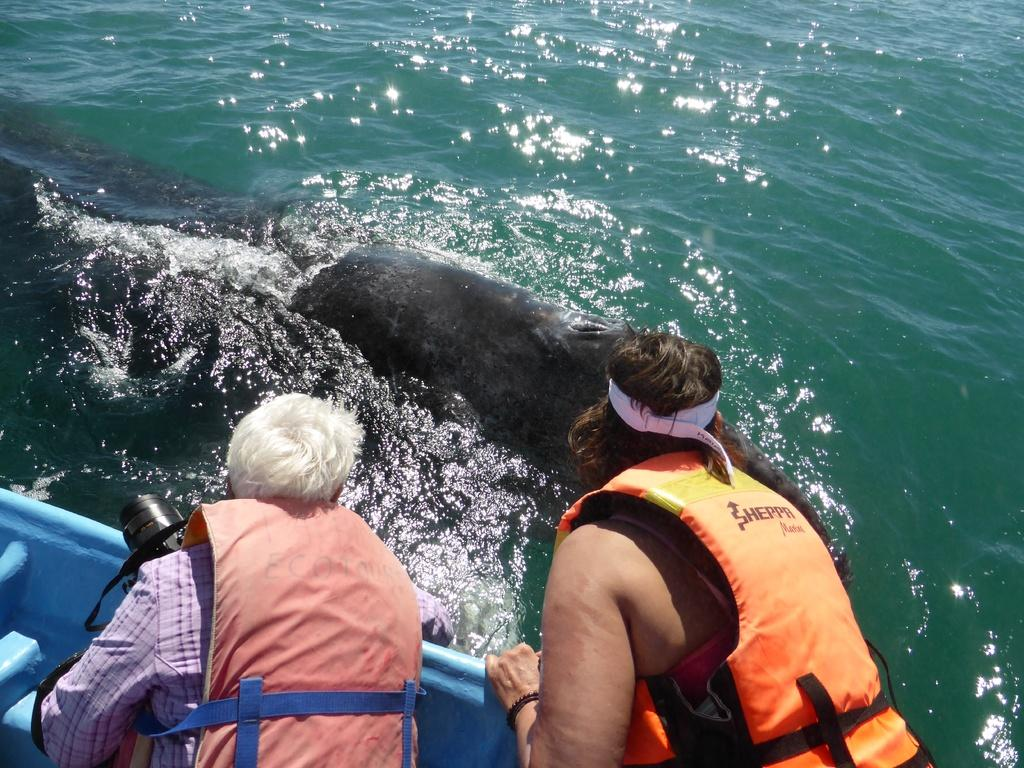What is the animal doing in the water? The animal is in the water, but the specific action is not mentioned in the facts. How many people are in the image? There are two persons in the image. What are the two persons doing in the image? The two persons are sailing on a boat. What might the person holding the camera be doing? The person holding the camera might be taking pictures or recording the scene. Where is the church located in the image? There is no mention of a church in the image or the provided facts. Are the two persons in the image brothers? The relationship between the two persons is not mentioned in the facts, so we cannot determine if they are brothers. 